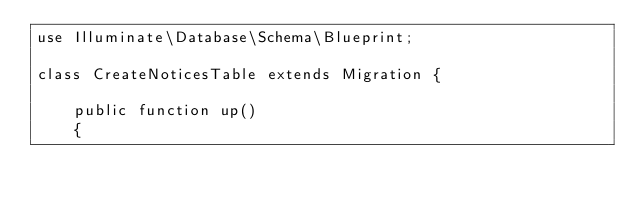<code> <loc_0><loc_0><loc_500><loc_500><_PHP_>use Illuminate\Database\Schema\Blueprint;

class CreateNoticesTable extends Migration {

	public function up()
	{</code> 